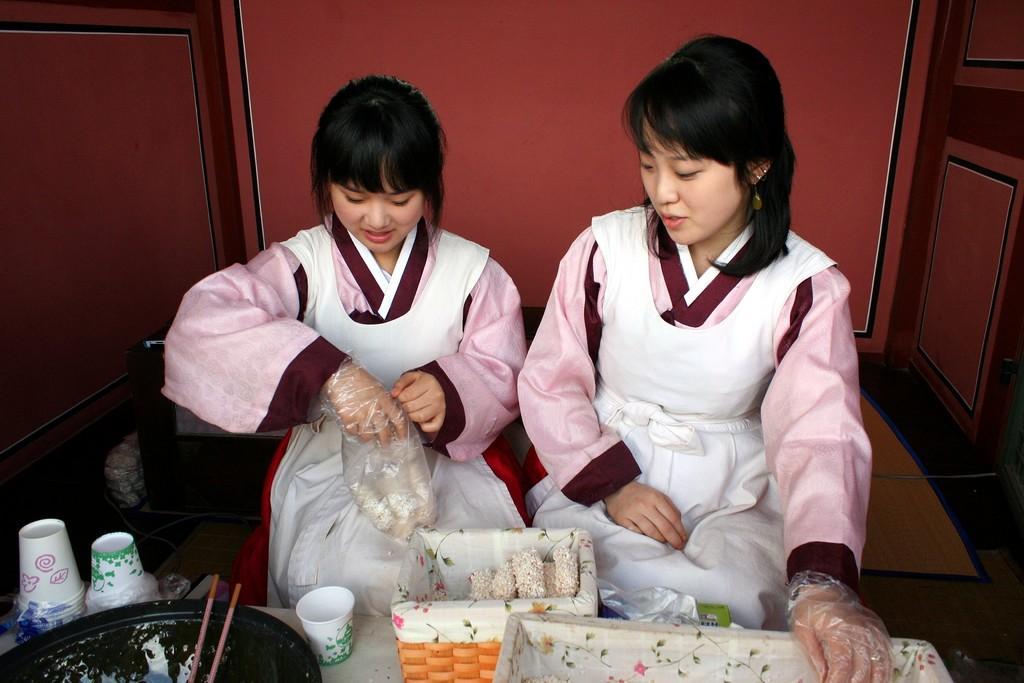Could you give a brief overview of what you see in this image? In this image, there are a few people. At the bottom, we can see some objects like a container, few cups and some boxes with food items. We can also see the ground and some wires. We can see some objects on the left. We can also see the wall. 